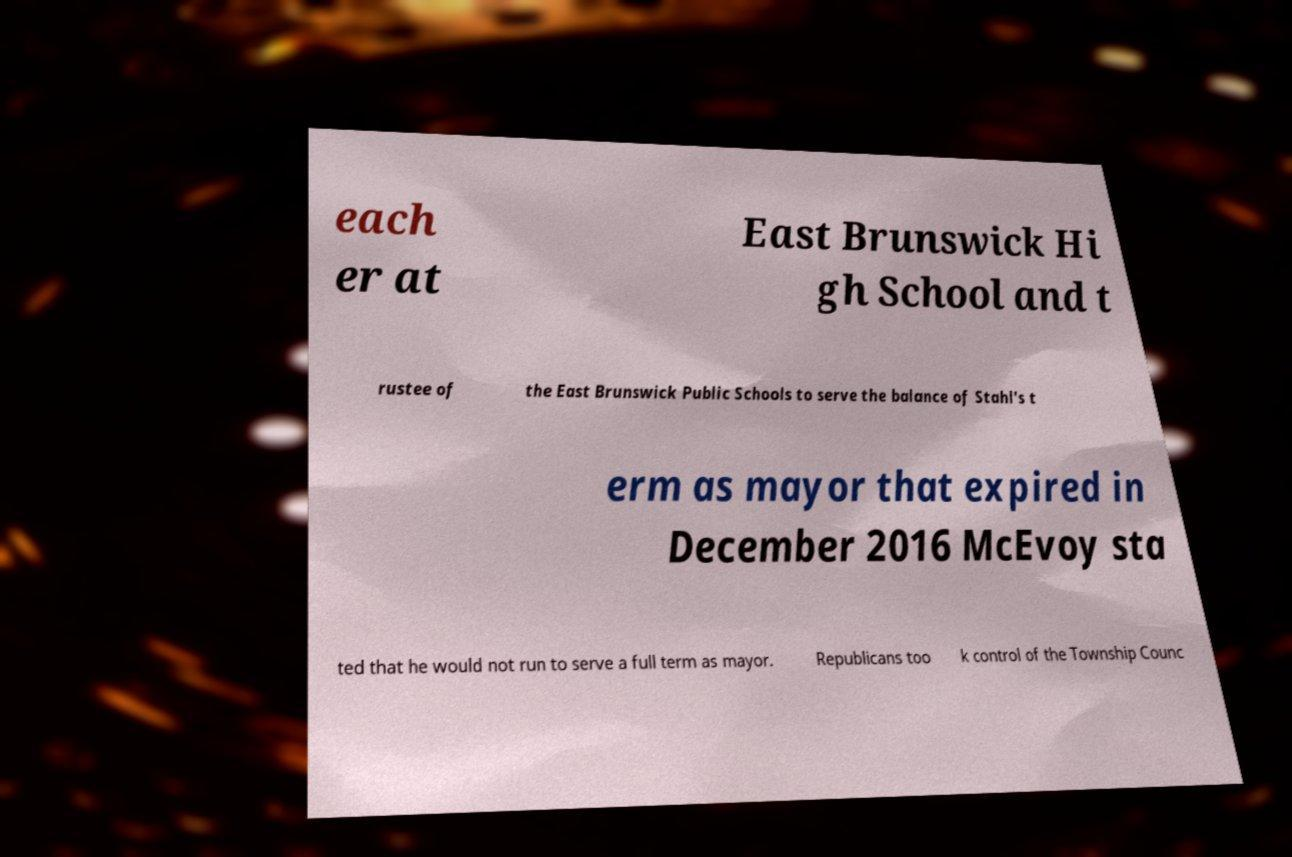There's text embedded in this image that I need extracted. Can you transcribe it verbatim? each er at East Brunswick Hi gh School and t rustee of the East Brunswick Public Schools to serve the balance of Stahl's t erm as mayor that expired in December 2016 McEvoy sta ted that he would not run to serve a full term as mayor. Republicans too k control of the Township Counc 